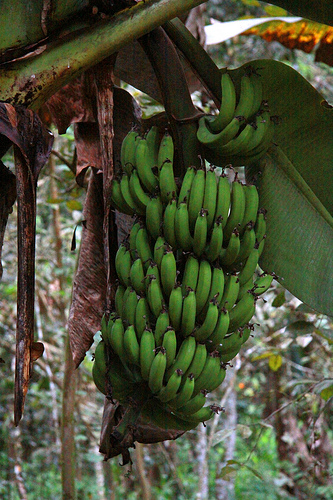Please provide a short description for this region: [0.42, 0.28, 0.61, 0.72]. The highlighted region features a dense cluster of green bananas. 